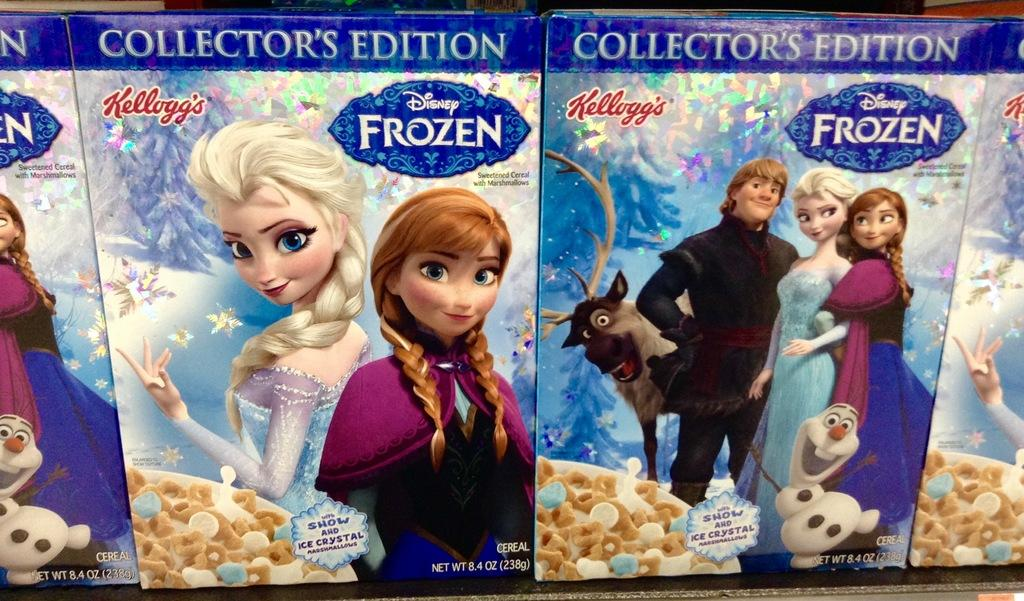What objects are present in the image? There are boxes in the image. What is depicted on the boxes? There are cartoon images on the boxes. How much sugar is contained in the boxes in the image? There is no information about the contents of the boxes, so we cannot determine the amount of sugar in them. 